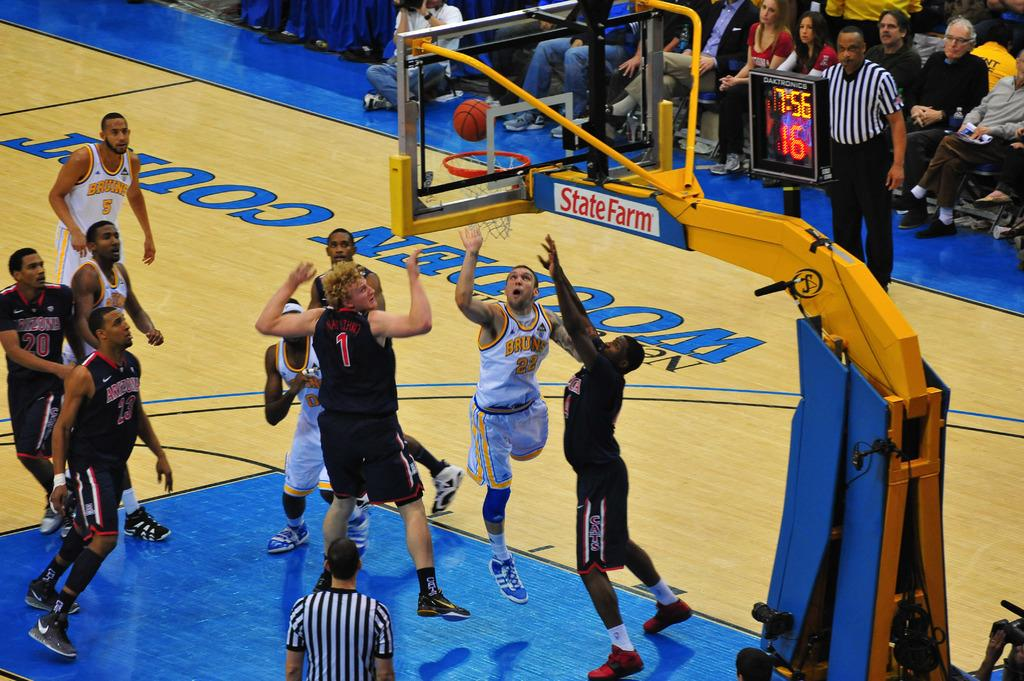Provide a one-sentence caption for the provided image. men playing basketball on a wooden court with state farm. 